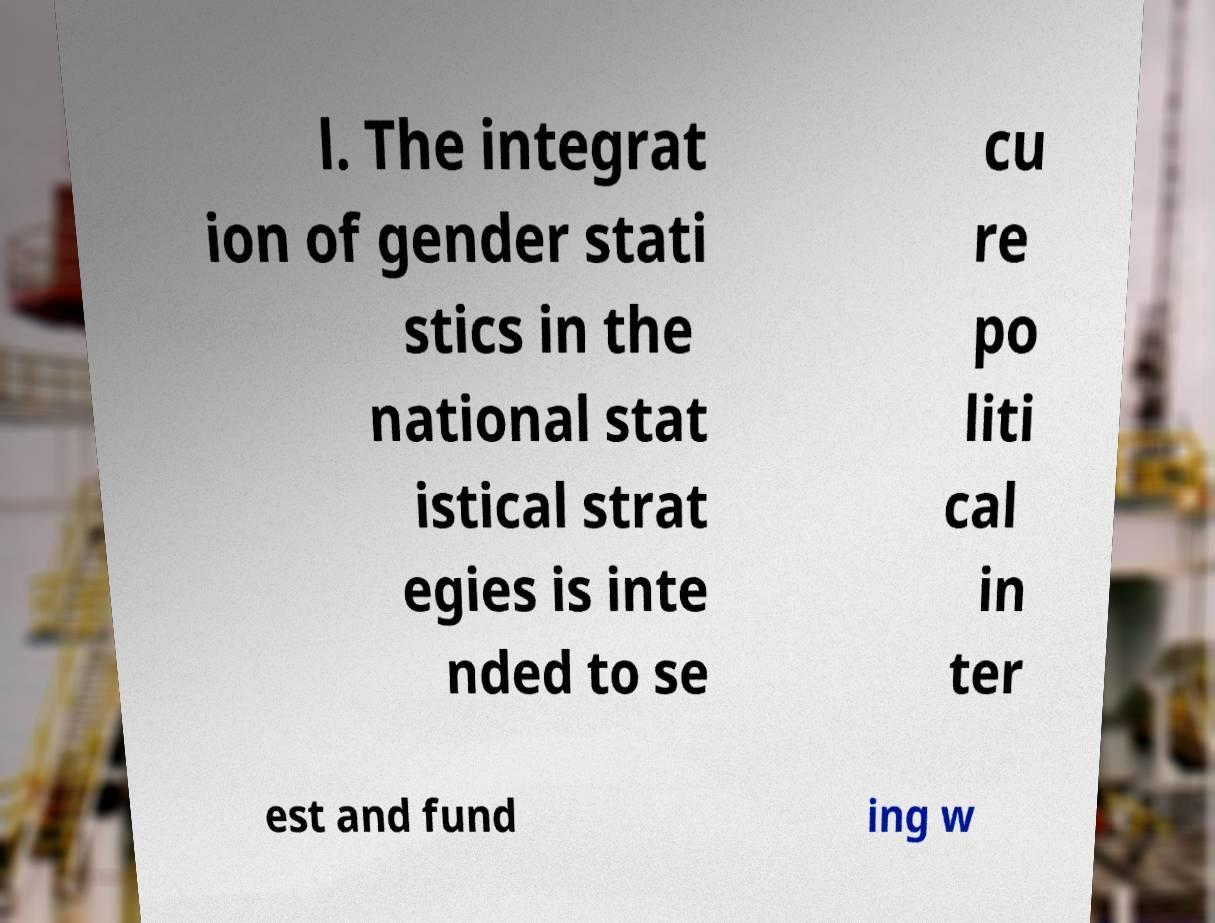Can you accurately transcribe the text from the provided image for me? l. The integrat ion of gender stati stics in the national stat istical strat egies is inte nded to se cu re po liti cal in ter est and fund ing w 